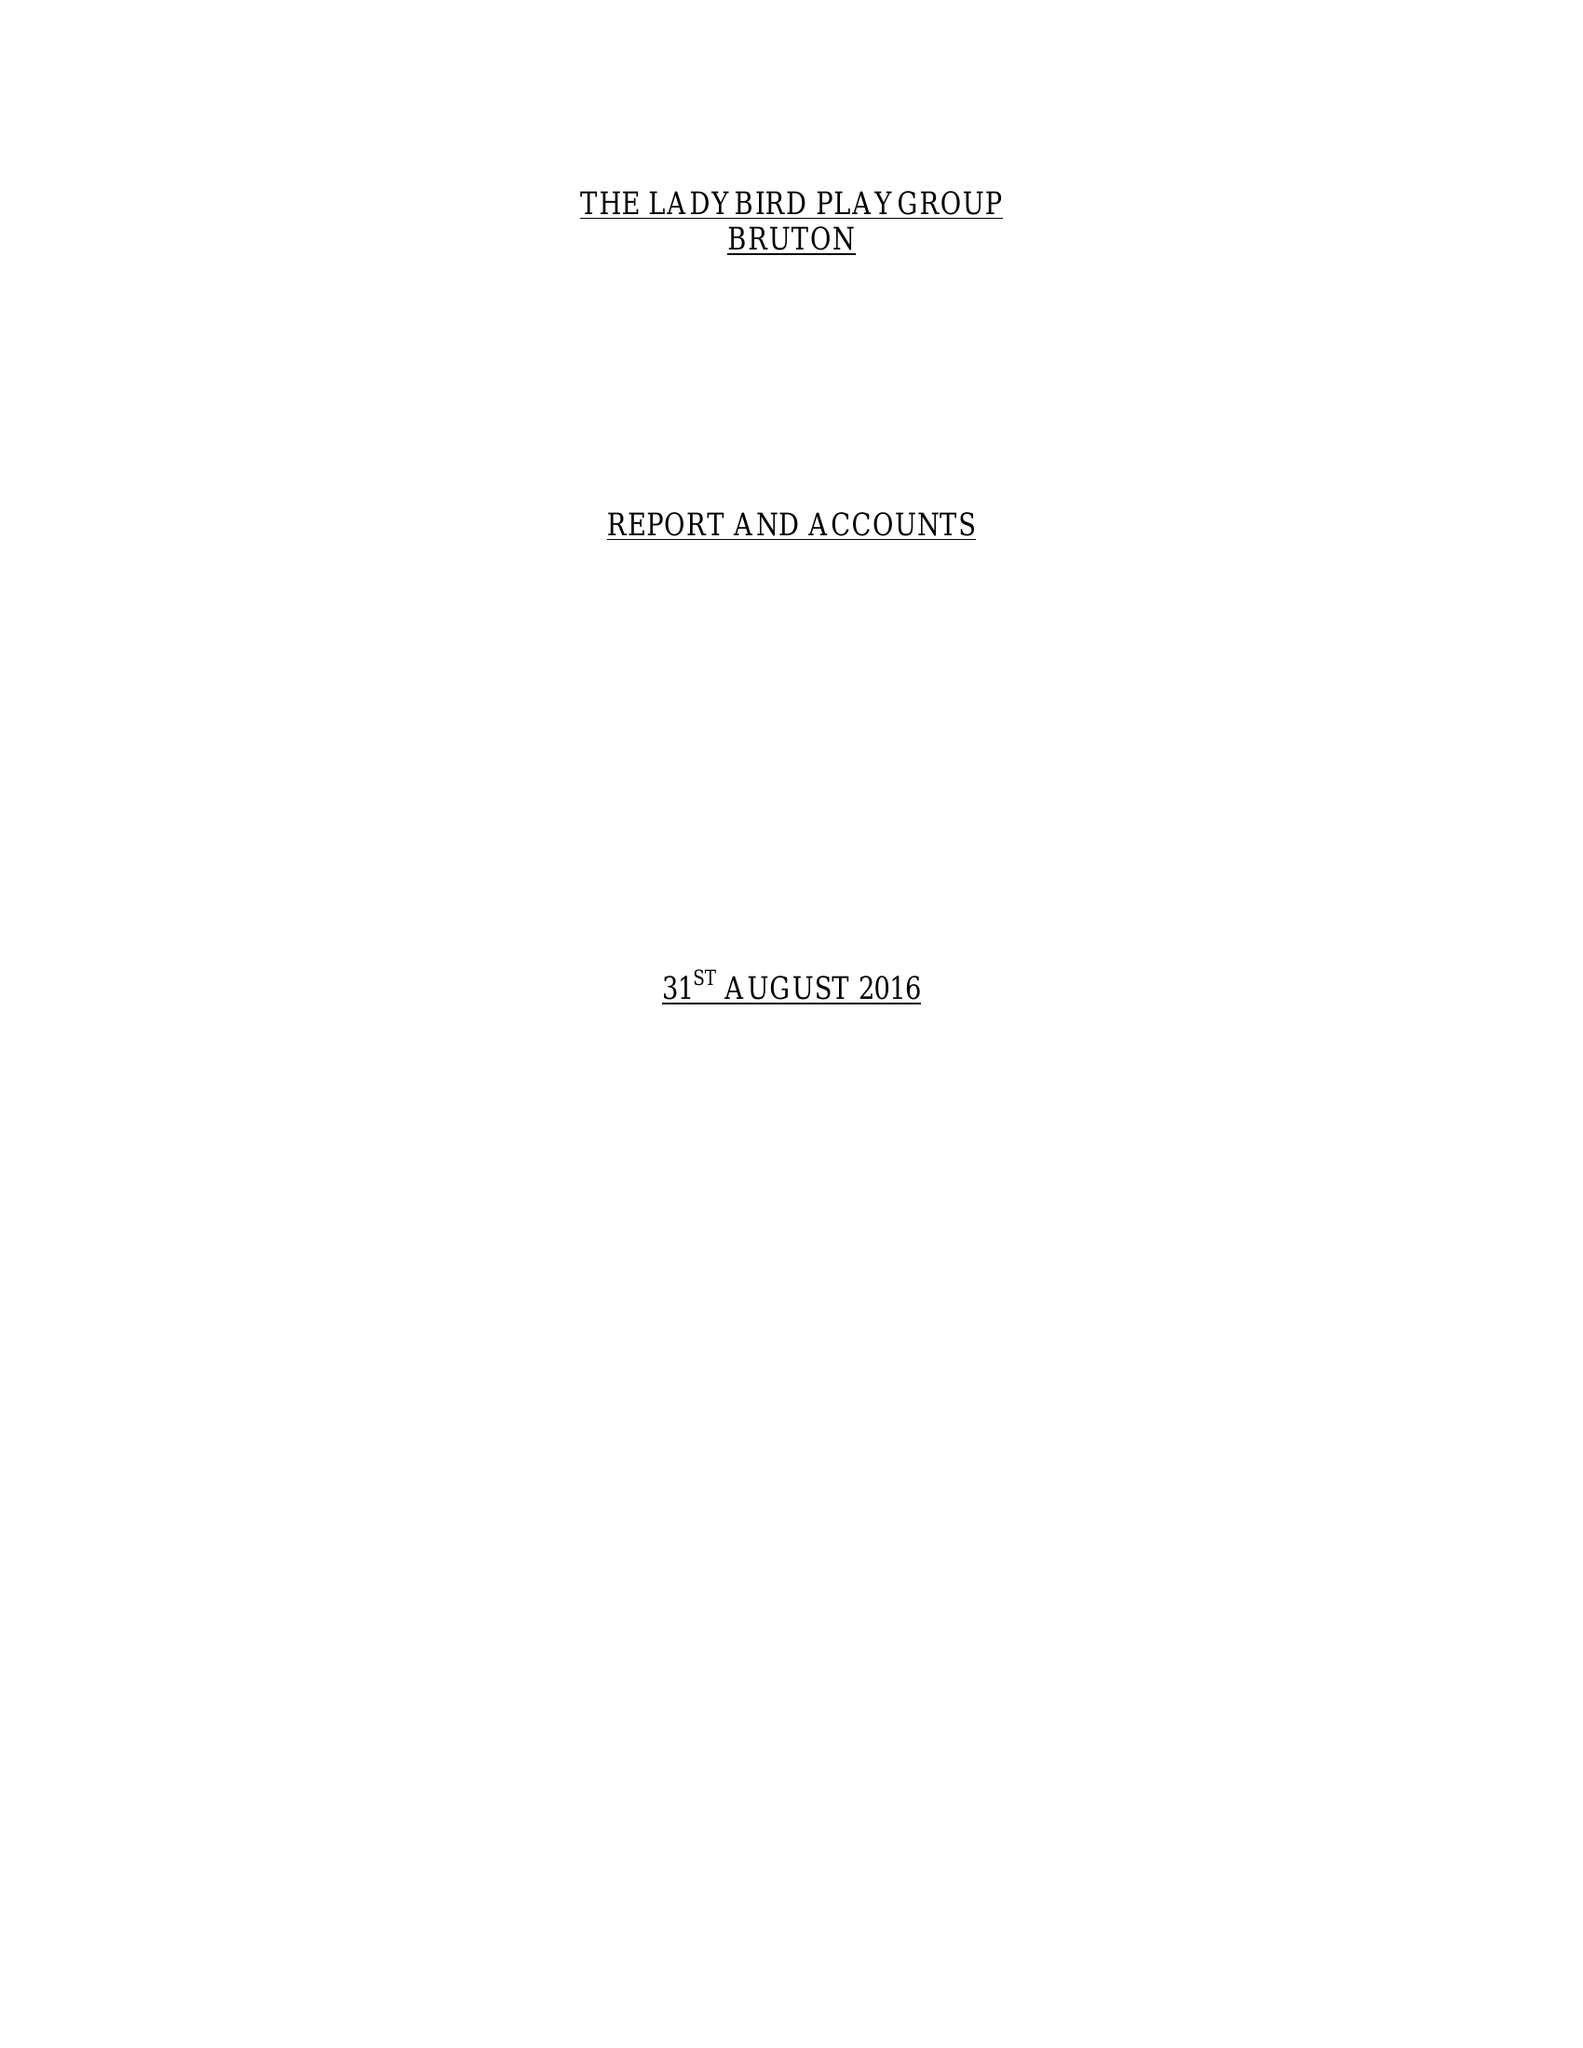What is the value for the report_date?
Answer the question using a single word or phrase. 2016-08-31 